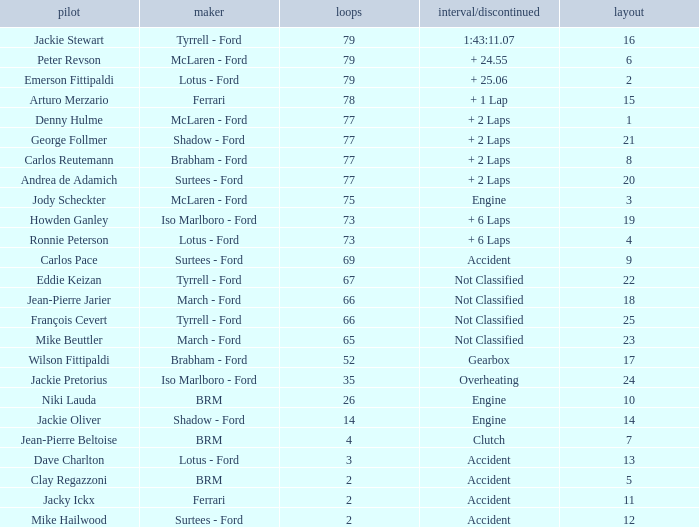How much time is required for less than 35 laps and less than 10 grids? Clutch, Accident. 